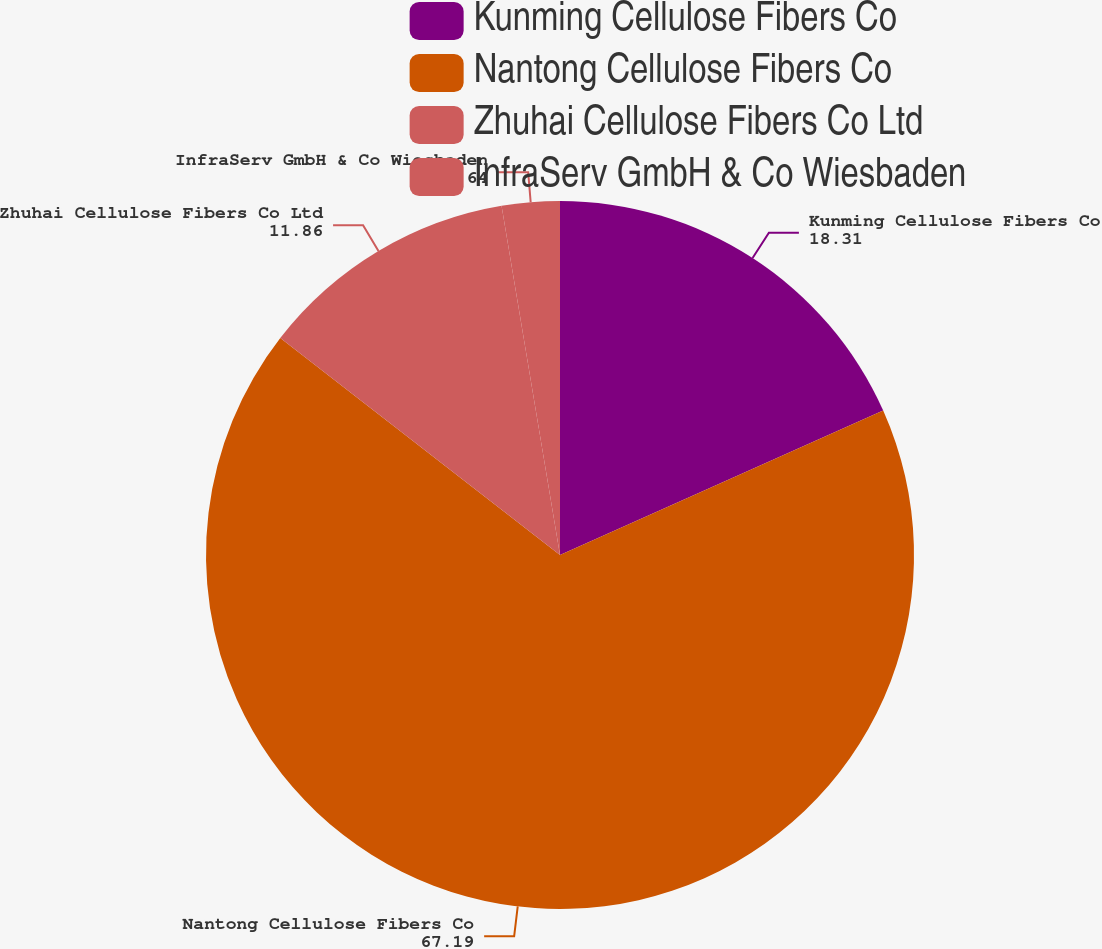Convert chart to OTSL. <chart><loc_0><loc_0><loc_500><loc_500><pie_chart><fcel>Kunming Cellulose Fibers Co<fcel>Nantong Cellulose Fibers Co<fcel>Zhuhai Cellulose Fibers Co Ltd<fcel>InfraServ GmbH & Co Wiesbaden<nl><fcel>18.31%<fcel>67.19%<fcel>11.86%<fcel>2.64%<nl></chart> 